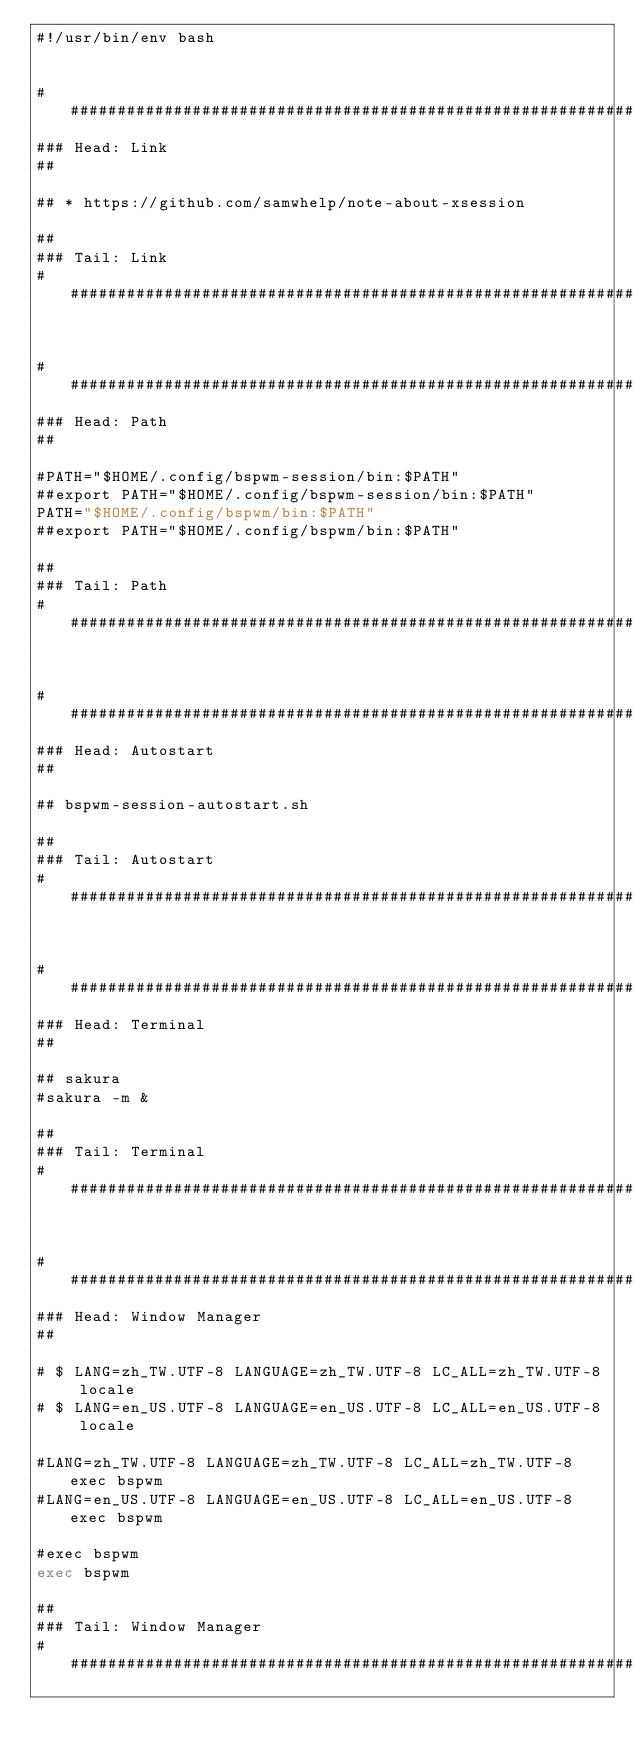<code> <loc_0><loc_0><loc_500><loc_500><_Bash_>#!/usr/bin/env bash


################################################################################
### Head: Link
##

## * https://github.com/samwhelp/note-about-xsession

##
### Tail: Link
################################################################################


################################################################################
### Head: Path
##

#PATH="$HOME/.config/bspwm-session/bin:$PATH"
##export PATH="$HOME/.config/bspwm-session/bin:$PATH"
PATH="$HOME/.config/bspwm/bin:$PATH"
##export PATH="$HOME/.config/bspwm/bin:$PATH"

##
### Tail: Path
################################################################################


################################################################################
### Head: Autostart
##

## bspwm-session-autostart.sh

##
### Tail: Autostart
################################################################################


################################################################################
### Head: Terminal
##

## sakura
#sakura -m &

##
### Tail: Terminal
################################################################################


################################################################################
### Head: Window Manager
##

# $ LANG=zh_TW.UTF-8 LANGUAGE=zh_TW.UTF-8 LC_ALL=zh_TW.UTF-8 locale
# $ LANG=en_US.UTF-8 LANGUAGE=en_US.UTF-8 LC_ALL=en_US.UTF-8 locale

#LANG=zh_TW.UTF-8 LANGUAGE=zh_TW.UTF-8 LC_ALL=zh_TW.UTF-8 exec bspwm
#LANG=en_US.UTF-8 LANGUAGE=en_US.UTF-8 LC_ALL=en_US.UTF-8 exec bspwm

#exec bspwm
exec bspwm

##
### Tail: Window Manager
################################################################################
</code> 